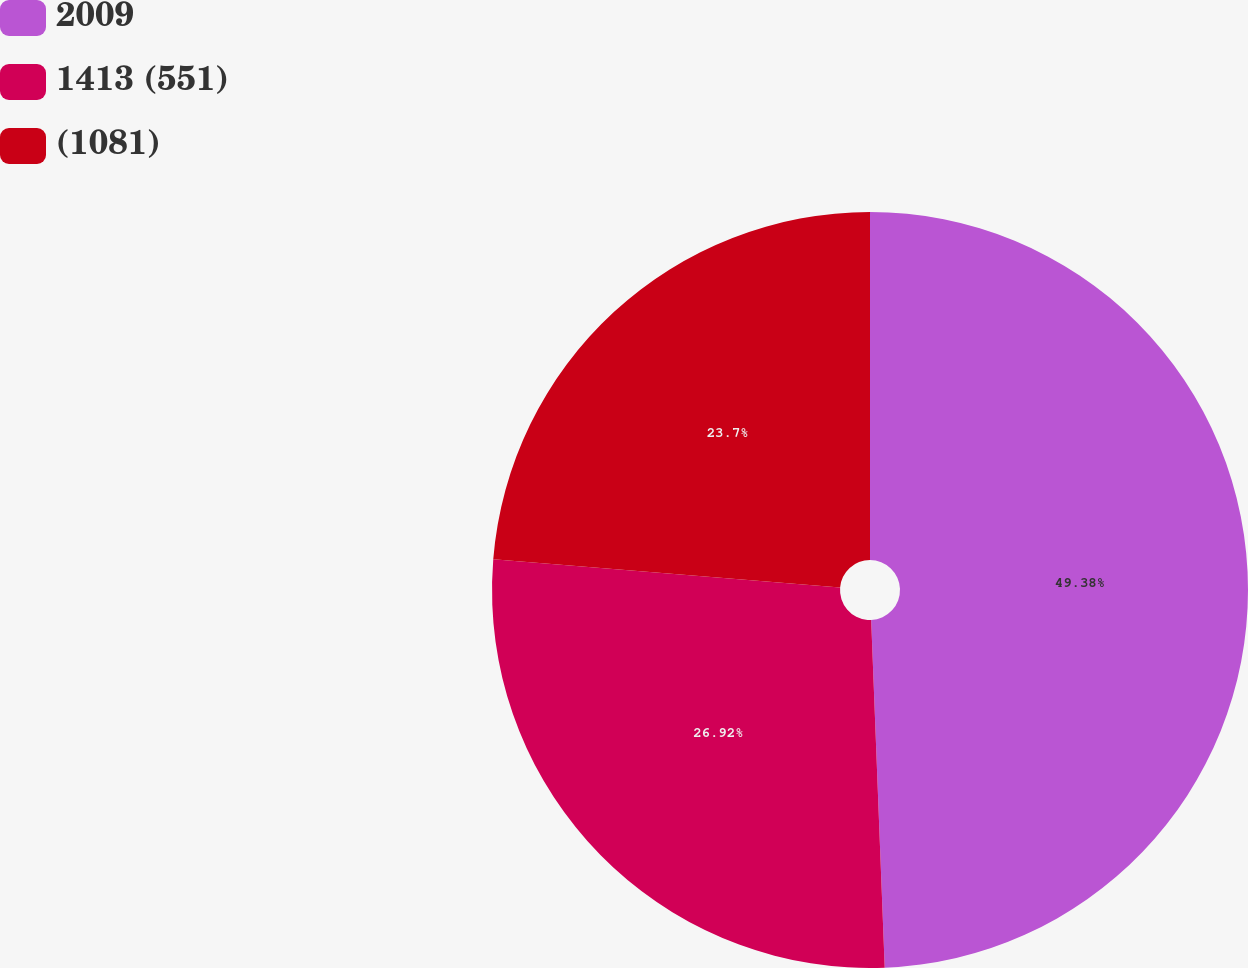Convert chart to OTSL. <chart><loc_0><loc_0><loc_500><loc_500><pie_chart><fcel>2009<fcel>1413 (551)<fcel>(1081)<nl><fcel>49.38%<fcel>26.92%<fcel>23.7%<nl></chart> 